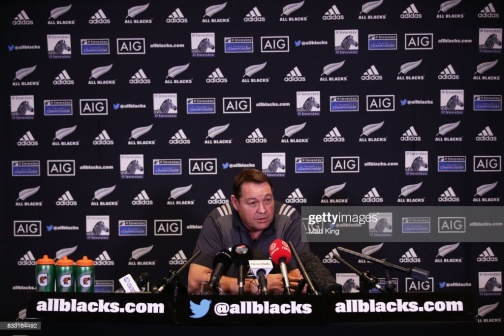How does the man's attire contribute to the setting or event? The man's blue shirt is informal yet neat and seems to be a strategic choice, balancing professionalism with approachability. The color contrasts well with the backdrop, allowing him to stand out and maintain visual interest, which is beneficial for on-camera appearances during press engagements or media events. 